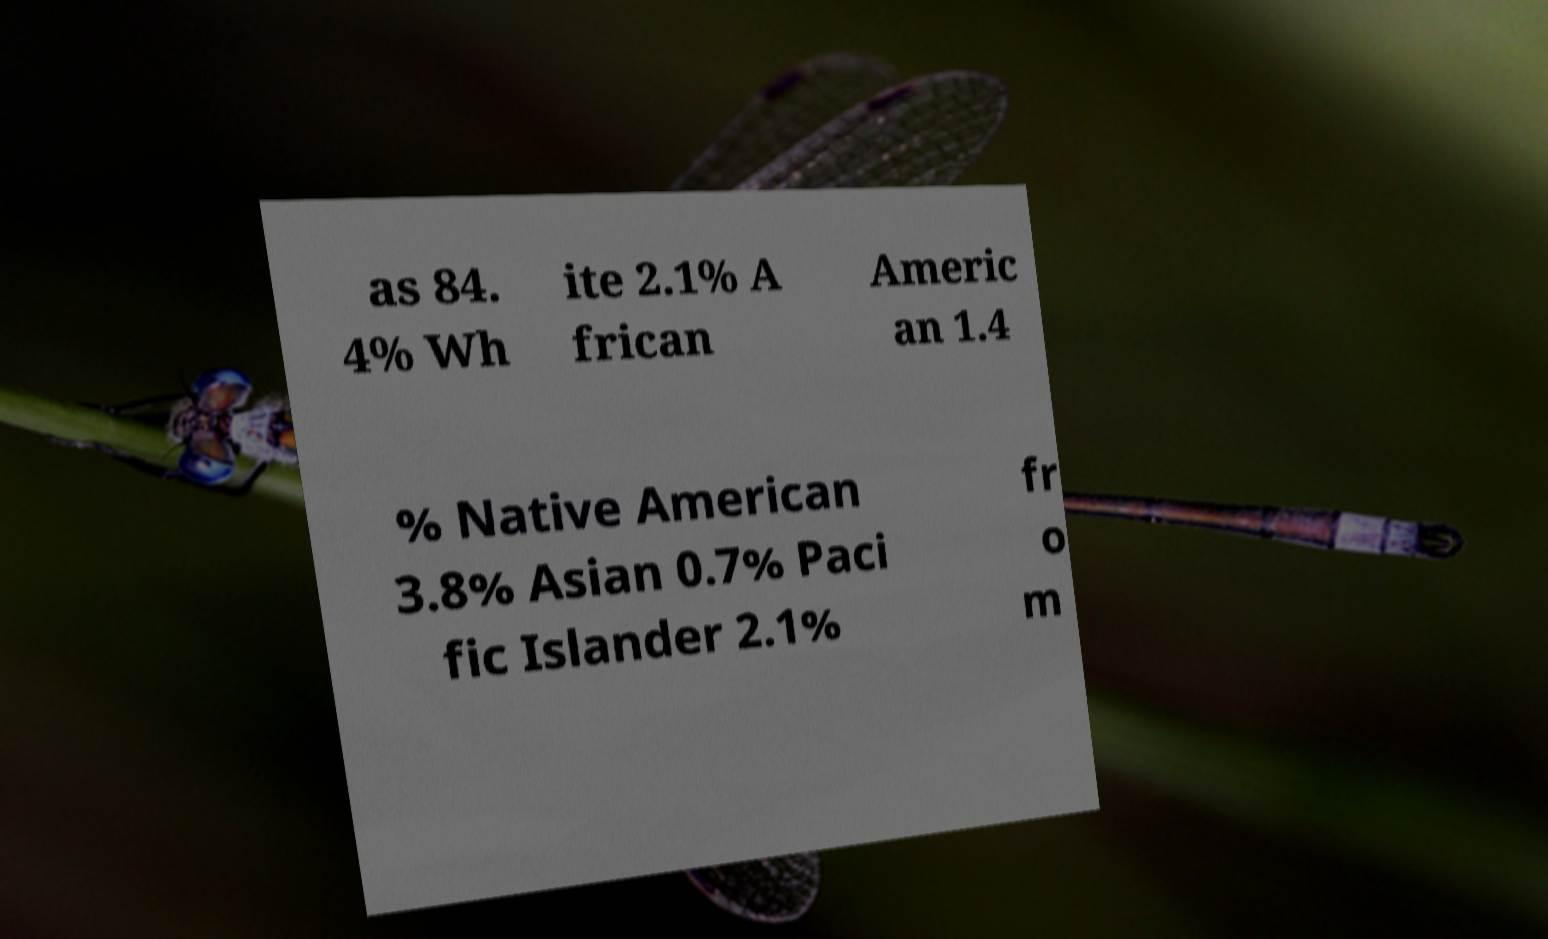Could you assist in decoding the text presented in this image and type it out clearly? as 84. 4% Wh ite 2.1% A frican Americ an 1.4 % Native American 3.8% Asian 0.7% Paci fic Islander 2.1% fr o m 